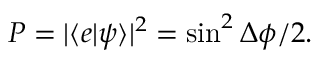<formula> <loc_0><loc_0><loc_500><loc_500>P = | \langle e | \psi \rangle | ^ { 2 } = \sin ^ { 2 } \Delta \phi / 2 .</formula> 